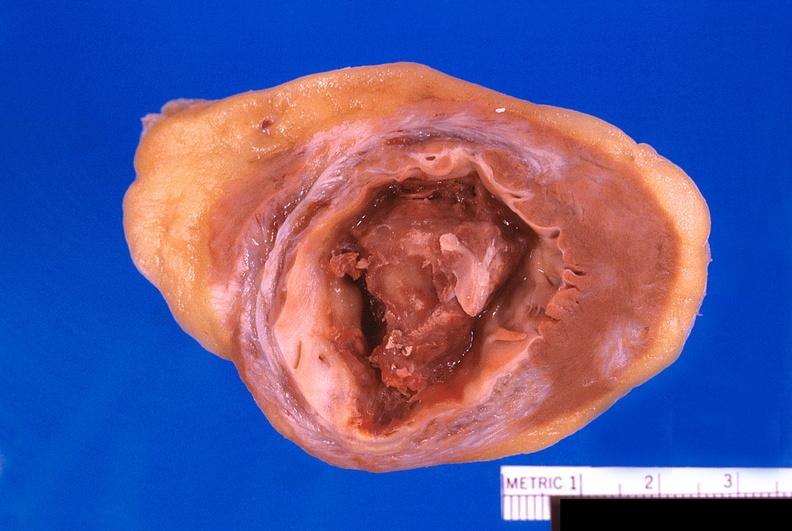where is this?
Answer the question using a single word or phrase. Heart 